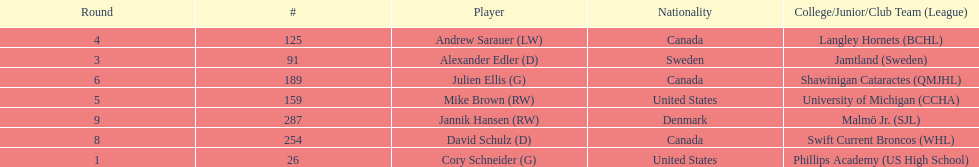Help me parse the entirety of this table. {'header': ['Round', '#', 'Player', 'Nationality', 'College/Junior/Club Team (League)'], 'rows': [['4', '125', 'Andrew Sarauer (LW)', 'Canada', 'Langley Hornets (BCHL)'], ['3', '91', 'Alexander Edler (D)', 'Sweden', 'Jamtland (Sweden)'], ['6', '189', 'Julien Ellis (G)', 'Canada', 'Shawinigan Cataractes (QMJHL)'], ['5', '159', 'Mike Brown (RW)', 'United States', 'University of Michigan (CCHA)'], ['9', '287', 'Jannik Hansen (RW)', 'Denmark', 'Malmö Jr. (SJL)'], ['8', '254', 'David Schulz (D)', 'Canada', 'Swift Current Broncos (WHL)'], ['1', '26', 'Cory Schneider (G)', 'United States', 'Phillips Academy (US High School)']]} How many goalies drafted? 2. 